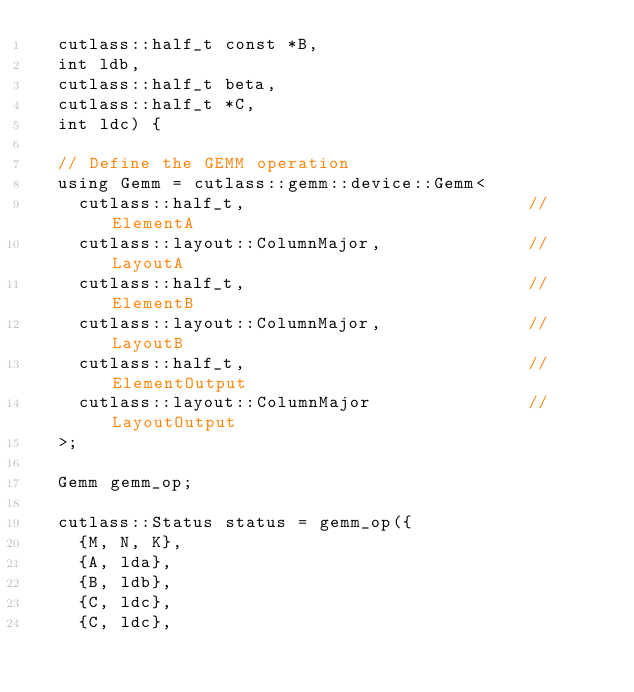<code> <loc_0><loc_0><loc_500><loc_500><_Cuda_>  cutlass::half_t const *B,
  int ldb,
  cutlass::half_t beta,
  cutlass::half_t *C,
  int ldc) {

  // Define the GEMM operation
  using Gemm = cutlass::gemm::device::Gemm<
    cutlass::half_t,                           // ElementA
    cutlass::layout::ColumnMajor,              // LayoutA
    cutlass::half_t,                           // ElementB
    cutlass::layout::ColumnMajor,              // LayoutB
    cutlass::half_t,                           // ElementOutput
    cutlass::layout::ColumnMajor               // LayoutOutput
  >;

  Gemm gemm_op;
  
  cutlass::Status status = gemm_op({
    {M, N, K},
    {A, lda},
    {B, ldb},
    {C, ldc},
    {C, ldc},</code> 